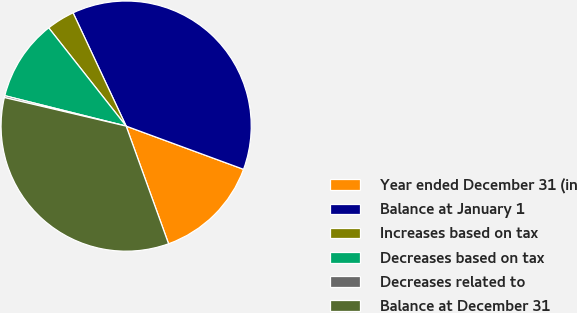<chart> <loc_0><loc_0><loc_500><loc_500><pie_chart><fcel>Year ended December 31 (in<fcel>Balance at January 1<fcel>Increases based on tax<fcel>Decreases based on tax<fcel>Decreases related to<fcel>Balance at December 31<nl><fcel>13.88%<fcel>37.59%<fcel>3.65%<fcel>10.47%<fcel>0.24%<fcel>34.18%<nl></chart> 